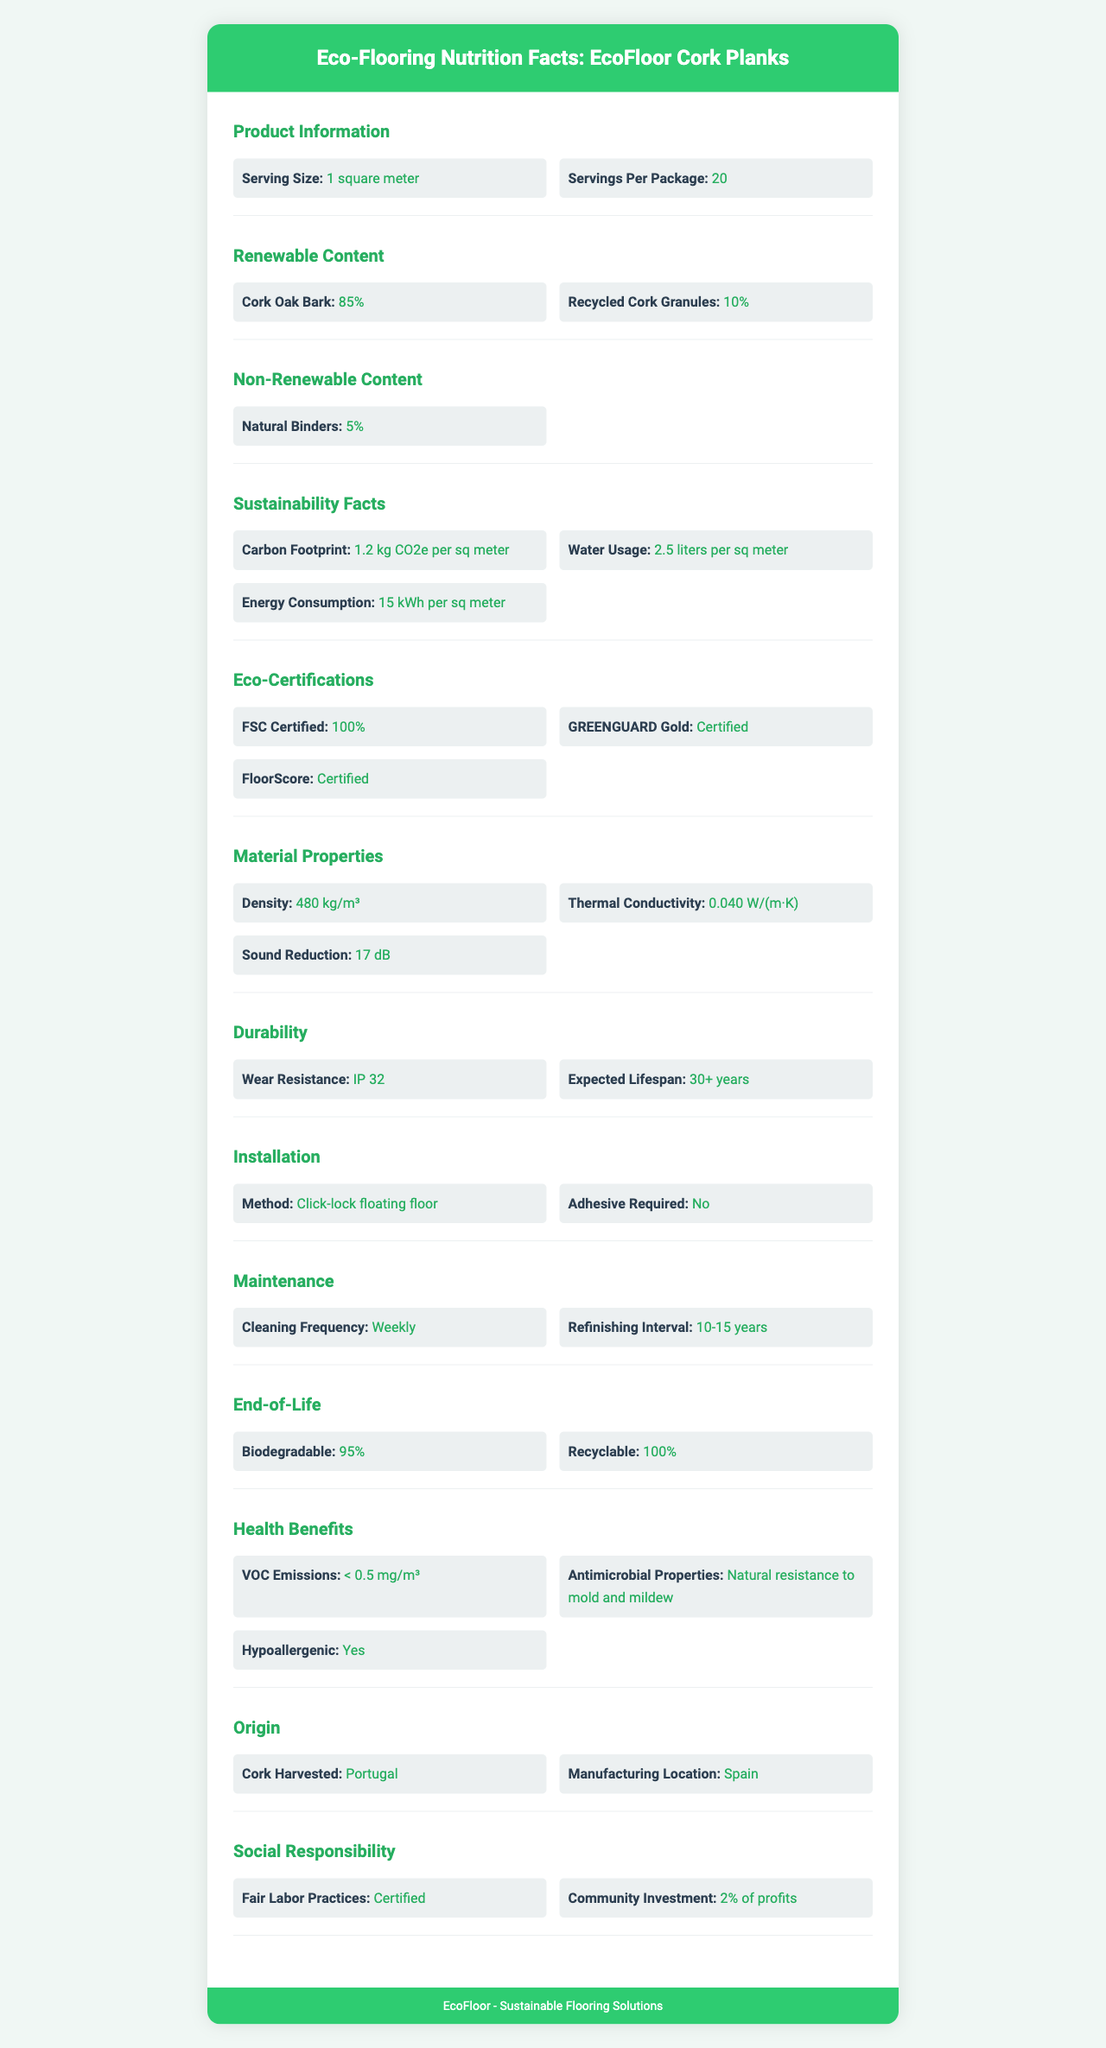what is the serving size for EcoFloor Cork Planks? The serving size is specified as "1 square meter" under the Product Information section in the document.
Answer: 1 square meter how many servings are there per package? The number of servings per package is listed as "20" under the Product Information section.
Answer: 20 what percentage of the product is composed of Cork Oak Bark? Under the Renewable Content section, it is mentioned that Cork Oak Bark makes up 85% of the renewable content.
Answer: 85% what is the carbon footprint per square meter for this product? The Sustainability Facts section shows the carbon footprint as "1.2 kg CO2e per sq meter".
Answer: 1.2 kg CO2e per square meter where is the cork harvested for EcoFloor Cork Planks? According to the Origin section, the cork is harvested in "Portugal".
Answer: Portugal which certification does EcoFloor Cork Planks have for ensuring low chemical emissions? A. FSC Certified B. GREENGUARD Gold C. FloorScore The Eco-Certifications section lists "GREENGUARD Gold" as a certification for EcoFloor Cork Planks.
Answer: B. GREENGUARD Gold what is the thermal conductivity of the material? A. 0.020 W/(m·K) B. 0.040 W/(m·K) C. 0.060 W/(m·K) Under Material Properties, the thermal conductivity is specified as "0.040 W/(m·K)".
Answer: B. 0.040 W/(m·K) is adhesive required for installation? The Installation section states "Adhesive Required: No".
Answer: No is the product hypoallergenic? The Health Benefits section lists "Hypoallergenic: Yes".
Answer: Yes what is the cleaning frequency recommended for EcoFloor Cork Planks? In the Maintenance section, it recommends a cleaning frequency of "Weekly".
Answer: Weekly describe the sustainability and eco-friendly aspects of EcoFloor Cork Planks. This summary includes data points from the Renewable Content, Eco-Certifications, Sustainability Facts, and End-of-Life sections, emphasizing the eco-friendly and sustainable aspects of the product.
Answer: The product is made primarily (85%) of Cork Oak Bark, a renewable resource, with an additional 10% of recycled cork granules. It has various eco-certifications, including FSC, GREENGUARD Gold, and FloorScore. The product has a relatively low carbon footprint (1.2 kg CO2e per sq meter) and is fully recyclable at the end of its life. what is the expected lifespan of EcoFloor Cork Planks? The Durability section notes an "Expected Lifespan" of "30+ years".
Answer: 30+ years can EcoFloor Cork Planks be recycled at the end of their life? The End-of-Life section lists the product as "Recyclable: 100%".
Answer: Yes what is the sound reduction capability of this flooring material? The Material Properties section indicates a sound reduction capability of "17 dB".
Answer: 17 dB when does the product need refinishing? The Maintenance section advises a "Refinishing Interval" of "10-15 years".
Answer: 10-15 years when will EcoFloor Cork Planks be available for purchase? The document does not contain information about the availability or release date of the product.
Answer: Cannot be determined 